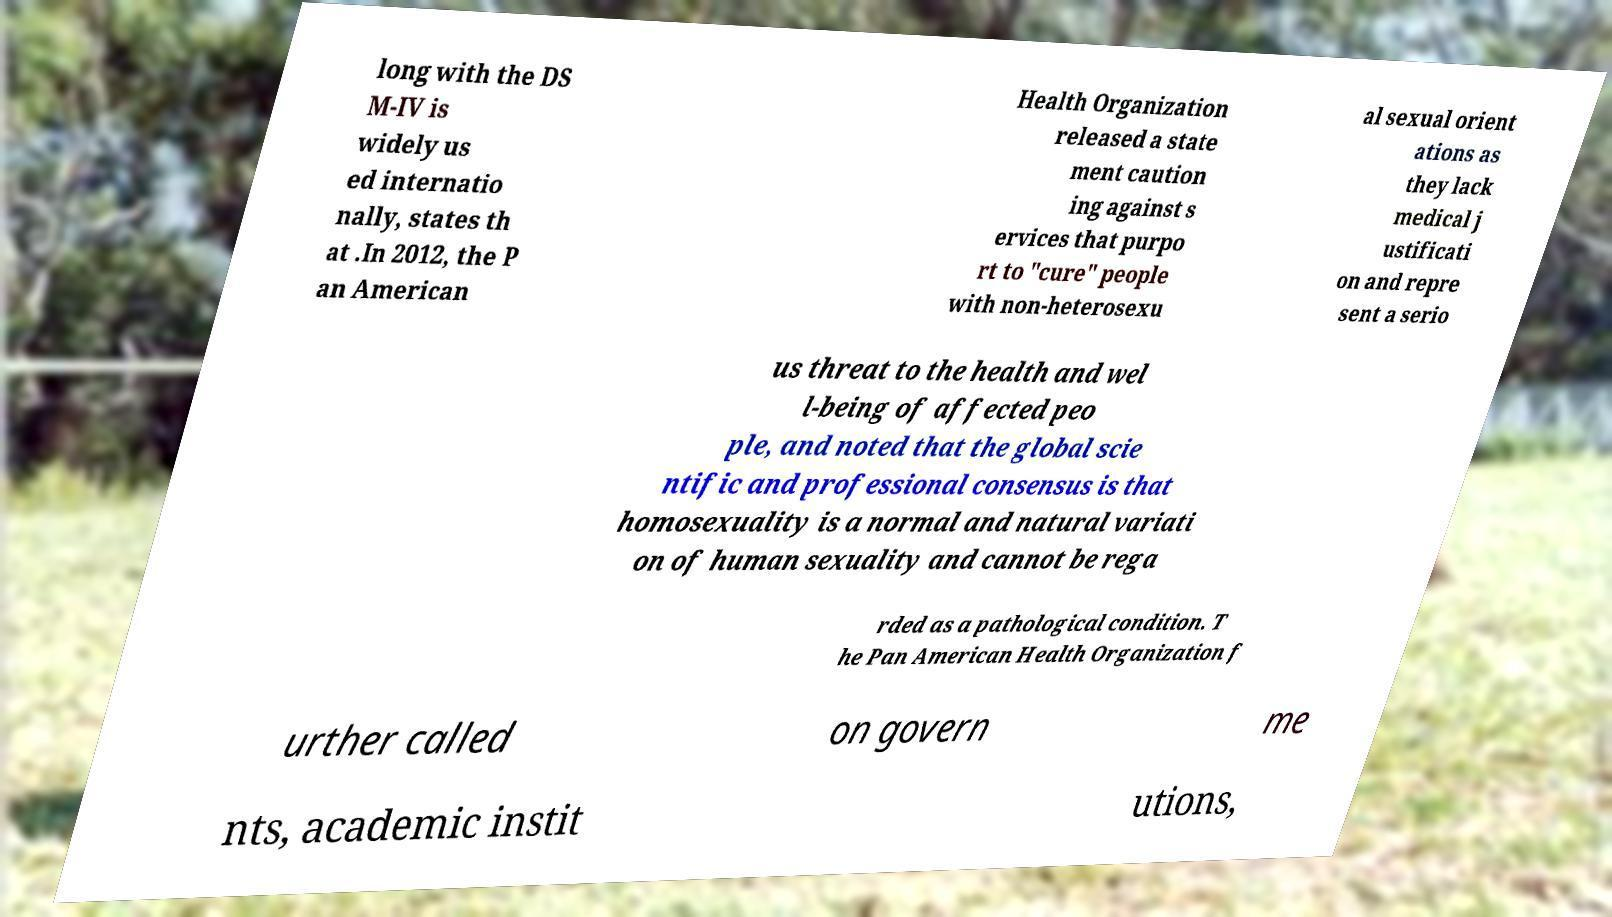For documentation purposes, I need the text within this image transcribed. Could you provide that? long with the DS M-IV is widely us ed internatio nally, states th at .In 2012, the P an American Health Organization released a state ment caution ing against s ervices that purpo rt to "cure" people with non-heterosexu al sexual orient ations as they lack medical j ustificati on and repre sent a serio us threat to the health and wel l-being of affected peo ple, and noted that the global scie ntific and professional consensus is that homosexuality is a normal and natural variati on of human sexuality and cannot be rega rded as a pathological condition. T he Pan American Health Organization f urther called on govern me nts, academic instit utions, 